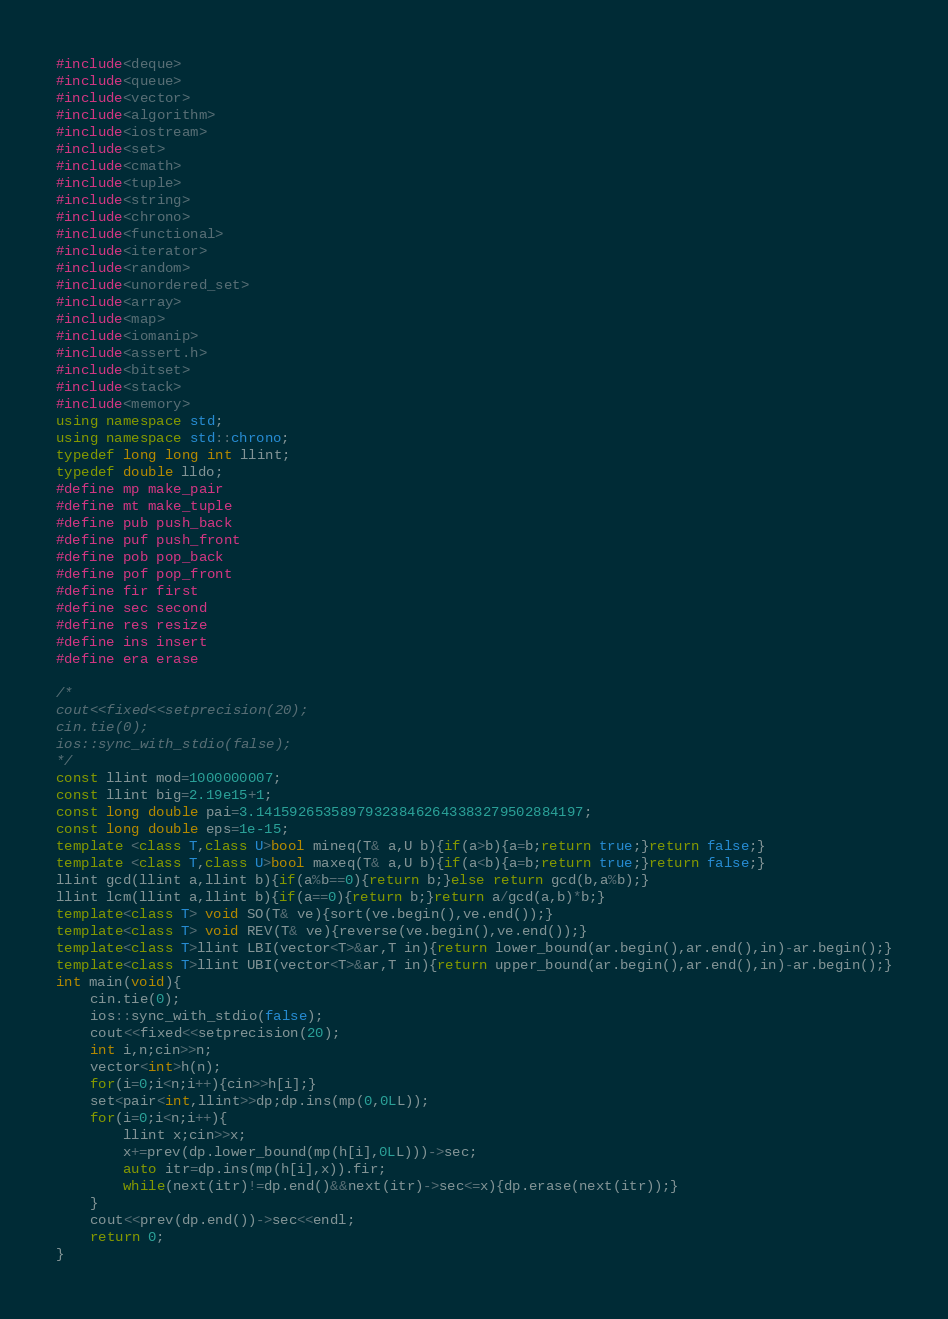<code> <loc_0><loc_0><loc_500><loc_500><_C++_>#include<deque>
#include<queue>
#include<vector>
#include<algorithm>
#include<iostream>
#include<set>
#include<cmath>
#include<tuple>
#include<string>
#include<chrono>
#include<functional>
#include<iterator>
#include<random>
#include<unordered_set>
#include<array>
#include<map>
#include<iomanip>
#include<assert.h>
#include<bitset>
#include<stack>
#include<memory>
using namespace std;
using namespace std::chrono;
typedef long long int llint;
typedef double lldo;
#define mp make_pair
#define mt make_tuple
#define pub push_back
#define puf push_front
#define pob pop_back
#define pof pop_front
#define fir first
#define sec second
#define res resize
#define ins insert
#define era erase

/*
cout<<fixed<<setprecision(20);
cin.tie(0);
ios::sync_with_stdio(false);
*/
const llint mod=1000000007;
const llint big=2.19e15+1;
const long double pai=3.141592653589793238462643383279502884197;
const long double eps=1e-15;
template <class T,class U>bool mineq(T& a,U b){if(a>b){a=b;return true;}return false;}
template <class T,class U>bool maxeq(T& a,U b){if(a<b){a=b;return true;}return false;}
llint gcd(llint a,llint b){if(a%b==0){return b;}else return gcd(b,a%b);}
llint lcm(llint a,llint b){if(a==0){return b;}return a/gcd(a,b)*b;}
template<class T> void SO(T& ve){sort(ve.begin(),ve.end());}
template<class T> void REV(T& ve){reverse(ve.begin(),ve.end());}
template<class T>llint LBI(vector<T>&ar,T in){return lower_bound(ar.begin(),ar.end(),in)-ar.begin();}
template<class T>llint UBI(vector<T>&ar,T in){return upper_bound(ar.begin(),ar.end(),in)-ar.begin();}
int main(void){
	cin.tie(0);
	ios::sync_with_stdio(false);
	cout<<fixed<<setprecision(20);
	int i,n;cin>>n;
	vector<int>h(n);
	for(i=0;i<n;i++){cin>>h[i];}
	set<pair<int,llint>>dp;dp.ins(mp(0,0LL));
	for(i=0;i<n;i++){
		llint x;cin>>x;
		x+=prev(dp.lower_bound(mp(h[i],0LL)))->sec;
		auto itr=dp.ins(mp(h[i],x)).fir;
		while(next(itr)!=dp.end()&&next(itr)->sec<=x){dp.erase(next(itr));}
	}
	cout<<prev(dp.end())->sec<<endl;
	return 0;
}
</code> 